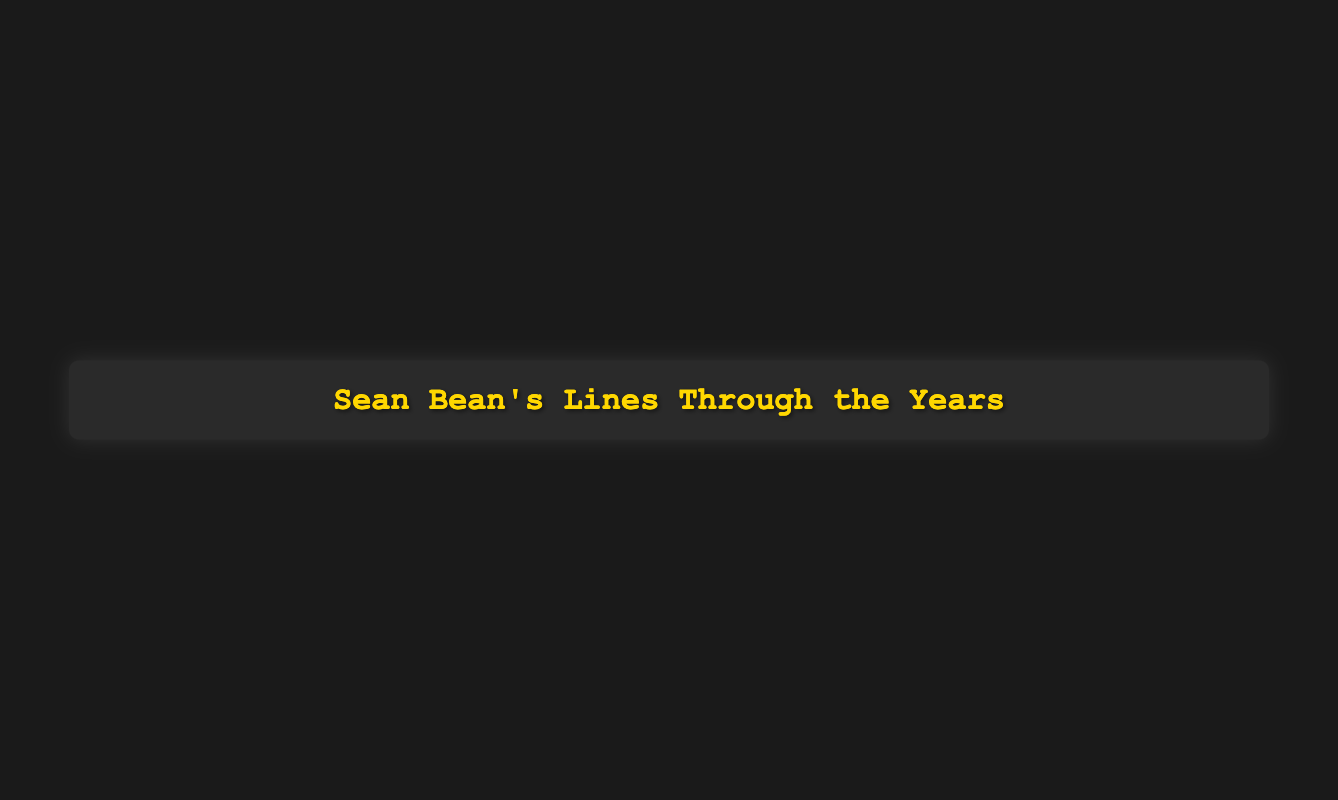What is the title of the chart? The chart's title is displayed prominently at the top of the figure.
Answer: Sean Bean's Dialogue Evolution How many lines did Sean Bean speak in "The Lord of the Rings: The Fellowship of the Ring"? Look for the data point labeled "The Lord of the Rings: The Fellowship of the Ring" in the scatter plot and refer to the y-axis for the number of lines spoken.
Answer: 210 Which movie or TV show in the data has the earliest release year? Identify the data point with the lowest x-axis value, which represents the earliest release year, along with its corresponding label.
Answer: The Field What is the color scale used for representing the number of lines spoken? Observe the color gradient and its corresponding color bar on the right side of the scatter plot, indicating the use of a specific color scale.
Answer: Viridis Which year has the maximum number of lines spoken by Sean Bean? Locate the highest data point on the y-axis and note the corresponding x-axis value (year) associated with it.
Answer: 2001 What is the average number of lines spoken by Sean Bean across all movies and TV shows? Calculate the sum of all lines spoken (120 + 75 + 95 + 113 + 210 + 87 + 130 + 145 + 185 + 65 + 76 + 50 + 78 + 120 + 160) and divide by the total number of data points (15).
Answer: 116.67 How many movies or TV shows had Sean Bean speak more than 150 lines? Count the number of data points that have a y-axis value (lines spoken) greater than 150.
Answer: 4 Which movie or TV show released in 2017, and how many lines did Sean Bean speak in it? Locate the data point for the year 2017 on the x-axis and refer to the label and y-axis value for that year.
Answer: Broken, 78 What is the range of release years for the movies and TV shows in the plot? Identify the minimum and maximum x-axis values (release years) in the scatter plot and calculate their difference.
Answer: The range is from 1988 to 2022, so 34 years Did Sean Bean speak more lines in "GoldenEye" or "Patriot Games"? Compare the y-axis values for the data points labeled "GoldenEye" and "Patriot Games" to determine which one has a higher count.
Answer: GoldenEye 